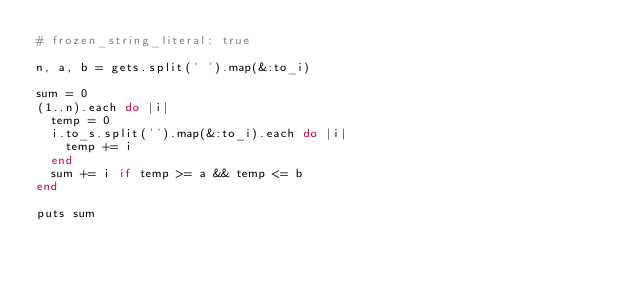Convert code to text. <code><loc_0><loc_0><loc_500><loc_500><_Ruby_># frozen_string_literal: true

n, a, b = gets.split(' ').map(&:to_i)

sum = 0
(1..n).each do |i|
  temp = 0
  i.to_s.split('').map(&:to_i).each do |i|
    temp += i
  end
  sum += i if temp >= a && temp <= b
end

puts sum
</code> 